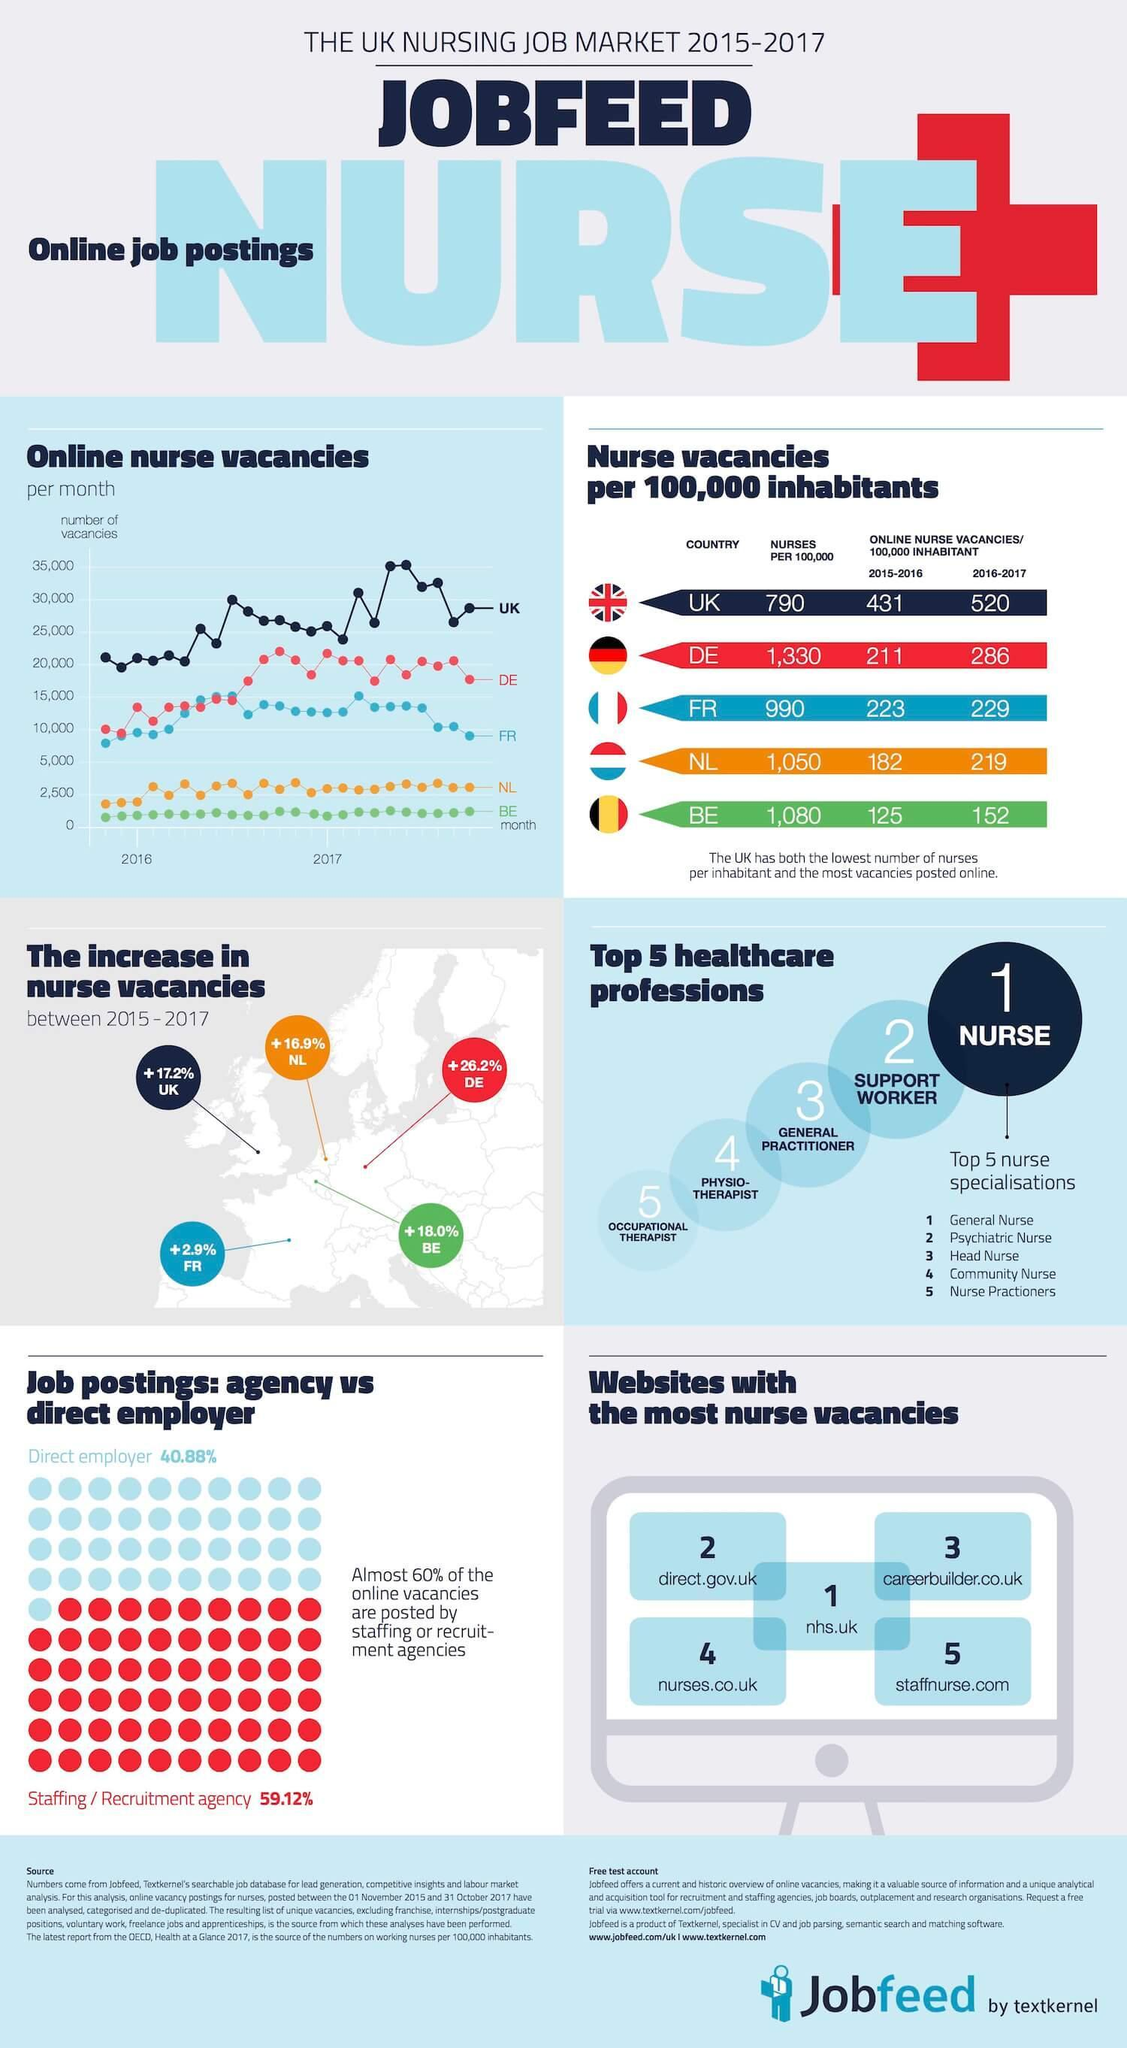Which country had the lowest percentage increase in nurse vacancies between 2015-2017?
Answer the question with a short phrase. FR How many country flags are shown under 'Nurse vacancies per 100,000 inhabitants'? 5 In which year did the number of vacancies in UK reach 35,000? 2017 Which website does not have .uk in its url? staffnurse.com What percent of online vacancies are not posted by staffing or recruitment agencies? 40% 